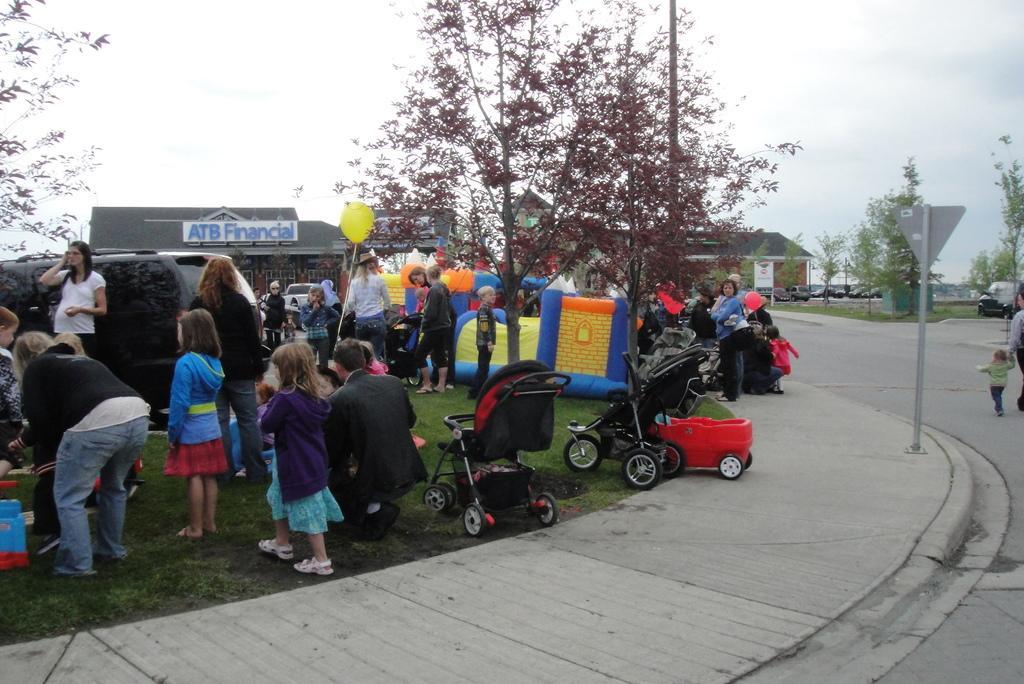How would you summarize this image in a sentence or two? There are groups of people standing. I can see the strollers. This looks like a pole, which is attached to a pole. I can see the balloons, which are yellow and red in color. These are the trees. I can see the buildings. This looks like a name board, which is at the top of the building. There is a car, which is black in color. This is the grass. I can see a pathway. In the background, I can see the cars, which are parked. On the right side of the image, I can a person and a kid walking on the road. 